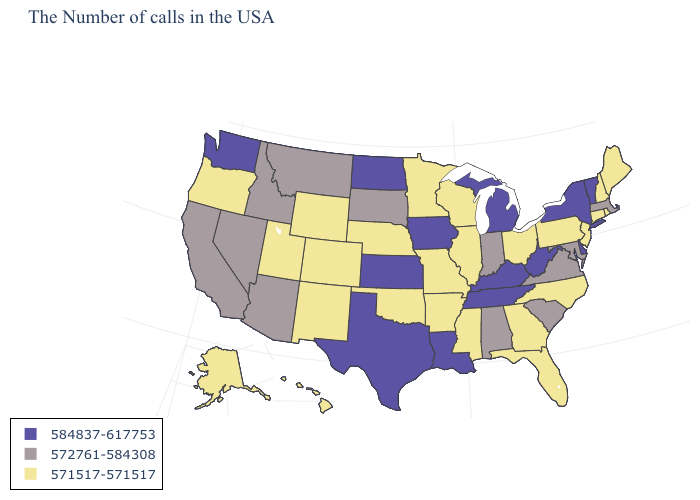Name the states that have a value in the range 572761-584308?
Quick response, please. Massachusetts, Maryland, Virginia, South Carolina, Indiana, Alabama, South Dakota, Montana, Arizona, Idaho, Nevada, California. Is the legend a continuous bar?
Write a very short answer. No. What is the value of Massachusetts?
Quick response, please. 572761-584308. What is the value of Florida?
Give a very brief answer. 571517-571517. Does Idaho have the lowest value in the West?
Be succinct. No. What is the lowest value in states that border Pennsylvania?
Short answer required. 571517-571517. Among the states that border Colorado , does Kansas have the lowest value?
Be succinct. No. Name the states that have a value in the range 572761-584308?
Keep it brief. Massachusetts, Maryland, Virginia, South Carolina, Indiana, Alabama, South Dakota, Montana, Arizona, Idaho, Nevada, California. Name the states that have a value in the range 584837-617753?
Short answer required. Vermont, New York, Delaware, West Virginia, Michigan, Kentucky, Tennessee, Louisiana, Iowa, Kansas, Texas, North Dakota, Washington. Does Washington have the highest value in the West?
Write a very short answer. Yes. Name the states that have a value in the range 571517-571517?
Keep it brief. Maine, Rhode Island, New Hampshire, Connecticut, New Jersey, Pennsylvania, North Carolina, Ohio, Florida, Georgia, Wisconsin, Illinois, Mississippi, Missouri, Arkansas, Minnesota, Nebraska, Oklahoma, Wyoming, Colorado, New Mexico, Utah, Oregon, Alaska, Hawaii. What is the lowest value in states that border Virginia?
Quick response, please. 571517-571517. How many symbols are there in the legend?
Write a very short answer. 3. Does Wyoming have the lowest value in the West?
Quick response, please. Yes. What is the value of Washington?
Be succinct. 584837-617753. 